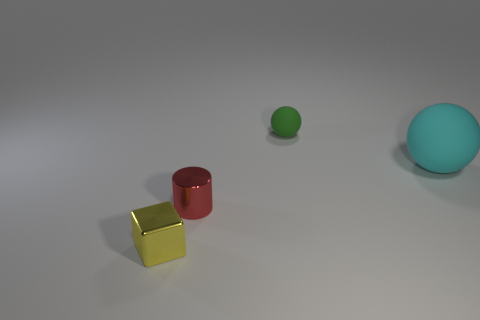What number of objects are large yellow matte spheres or balls in front of the small ball?
Your answer should be very brief. 1. There is a thing that is both on the left side of the big thing and behind the tiny red metallic cylinder; what is its shape?
Keep it short and to the point. Sphere. There is a sphere behind the rubber ball to the right of the tiny green rubber sphere; what is it made of?
Your answer should be compact. Rubber. Does the sphere in front of the green matte object have the same material as the small green object?
Provide a short and direct response. Yes. There is a rubber object on the right side of the green object; how big is it?
Provide a succinct answer. Large. There is a small object that is behind the cyan object; are there any big cyan matte things that are behind it?
Give a very brief answer. No. Does the rubber sphere that is left of the big cyan ball have the same color as the thing that is left of the metallic cylinder?
Your answer should be compact. No. The small metal cylinder has what color?
Give a very brief answer. Red. Are there any other things of the same color as the big rubber ball?
Your answer should be very brief. No. What is the color of the small object that is both to the right of the tiny yellow thing and in front of the large cyan sphere?
Your response must be concise. Red. 